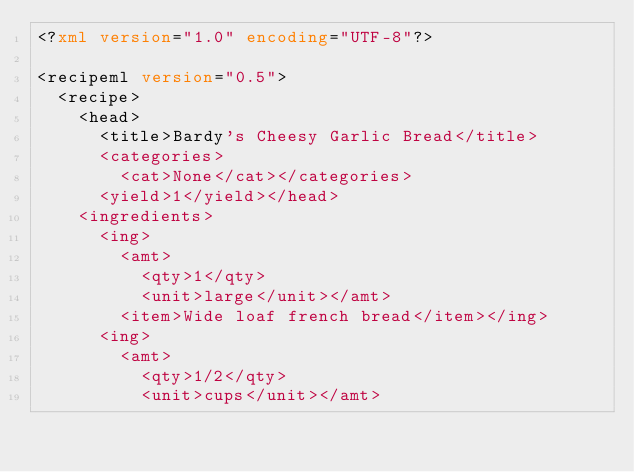Convert code to text. <code><loc_0><loc_0><loc_500><loc_500><_XML_><?xml version="1.0" encoding="UTF-8"?>

<recipeml version="0.5">
  <recipe>
    <head>
      <title>Bardy's Cheesy Garlic Bread</title>
      <categories>
        <cat>None</cat></categories>
      <yield>1</yield></head>
    <ingredients>
      <ing>
        <amt>
          <qty>1</qty>
          <unit>large</unit></amt>
        <item>Wide loaf french bread</item></ing>
      <ing>
        <amt>
          <qty>1/2</qty>
          <unit>cups</unit></amt></code> 